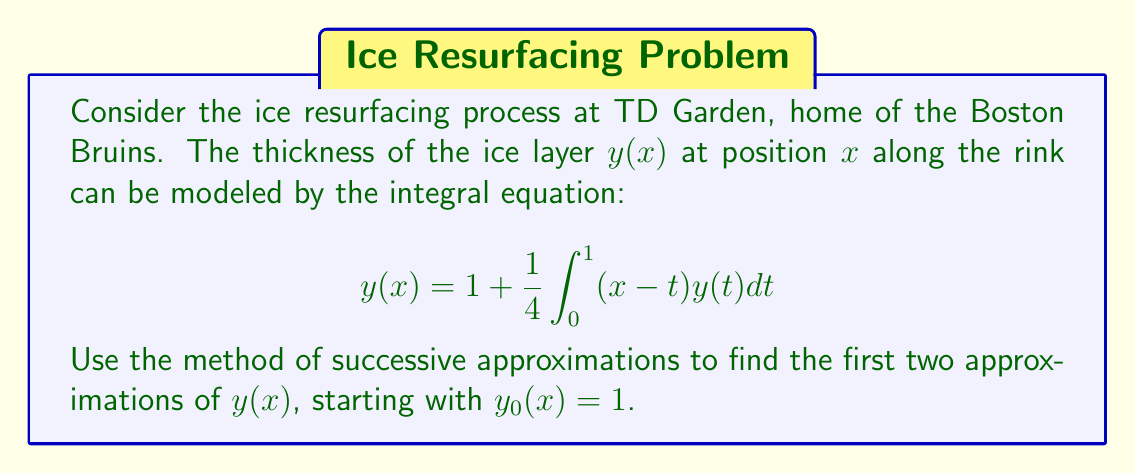Teach me how to tackle this problem. Let's apply the method of successive approximations:

1) We start with $y_0(x) = 1$.

2) For the first approximation $y_1(x)$:
   $$y_1(x) = 1 + \frac{1}{4}\int_0^1 (x-t)y_0(t)dt$$
   $$= 1 + \frac{1}{4}\int_0^1 (x-t)dt$$
   $$= 1 + \frac{1}{4}[xt - \frac{t^2}{2}]_0^1$$
   $$= 1 + \frac{1}{4}(x - \frac{1}{2})$$
   $$= 1 + \frac{x}{4} - \frac{1}{8}$$
   $$= \frac{7}{8} + \frac{x}{4}$$

3) For the second approximation $y_2(x)$:
   $$y_2(x) = 1 + \frac{1}{4}\int_0^1 (x-t)y_1(t)dt$$
   $$= 1 + \frac{1}{4}\int_0^1 (x-t)(\frac{7}{8} + \frac{t}{4})dt$$
   $$= 1 + \frac{1}{4}[\frac{7}{8}\int_0^1 (x-t)dt + \frac{1}{4}\int_0^1 (x-t)tdt]$$
   $$= 1 + \frac{1}{4}[\frac{7}{8}(x - \frac{1}{2}) + \frac{1}{4}(x\frac{1}{2} - \frac{1}{3})]$$
   $$= 1 + \frac{7x}{32} - \frac{7}{64} + \frac{x}{32} - \frac{1}{48}$$
   $$= \frac{61}{64} + \frac{x}{4}$$

Therefore, the first two approximations are:
$y_1(x) = \frac{7}{8} + \frac{x}{4}$ and $y_2(x) = \frac{61}{64} + \frac{x}{4}$.
Answer: $y_1(x) = \frac{7}{8} + \frac{x}{4}$, $y_2(x) = \frac{61}{64} + \frac{x}{4}$ 